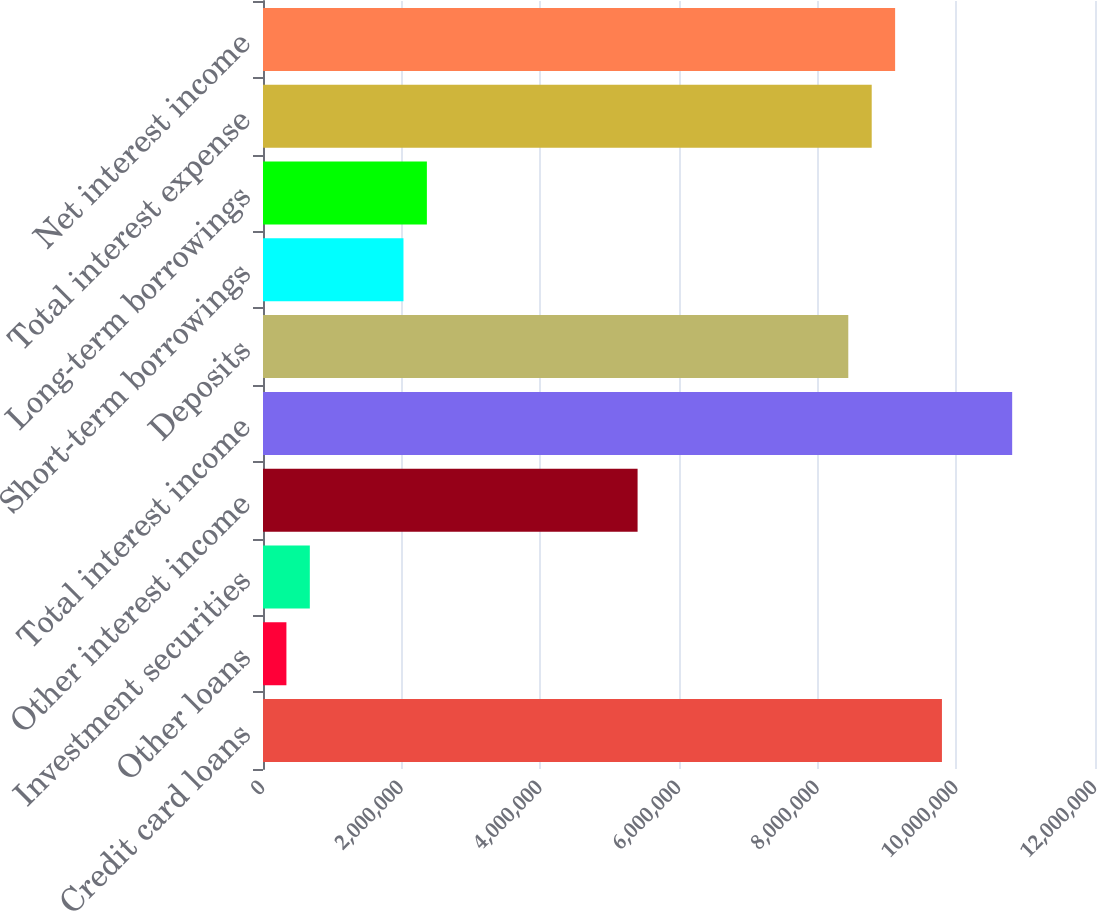Convert chart to OTSL. <chart><loc_0><loc_0><loc_500><loc_500><bar_chart><fcel>Credit card loans<fcel>Other loans<fcel>Investment securities<fcel>Other interest income<fcel>Total interest income<fcel>Deposits<fcel>Short-term borrowings<fcel>Long-term borrowings<fcel>Total interest expense<fcel>Net interest income<nl><fcel>9.79238e+06<fcel>337668<fcel>675336<fcel>5.40269e+06<fcel>1.08054e+07<fcel>8.4417e+06<fcel>2.02601e+06<fcel>2.36368e+06<fcel>8.77937e+06<fcel>9.11704e+06<nl></chart> 